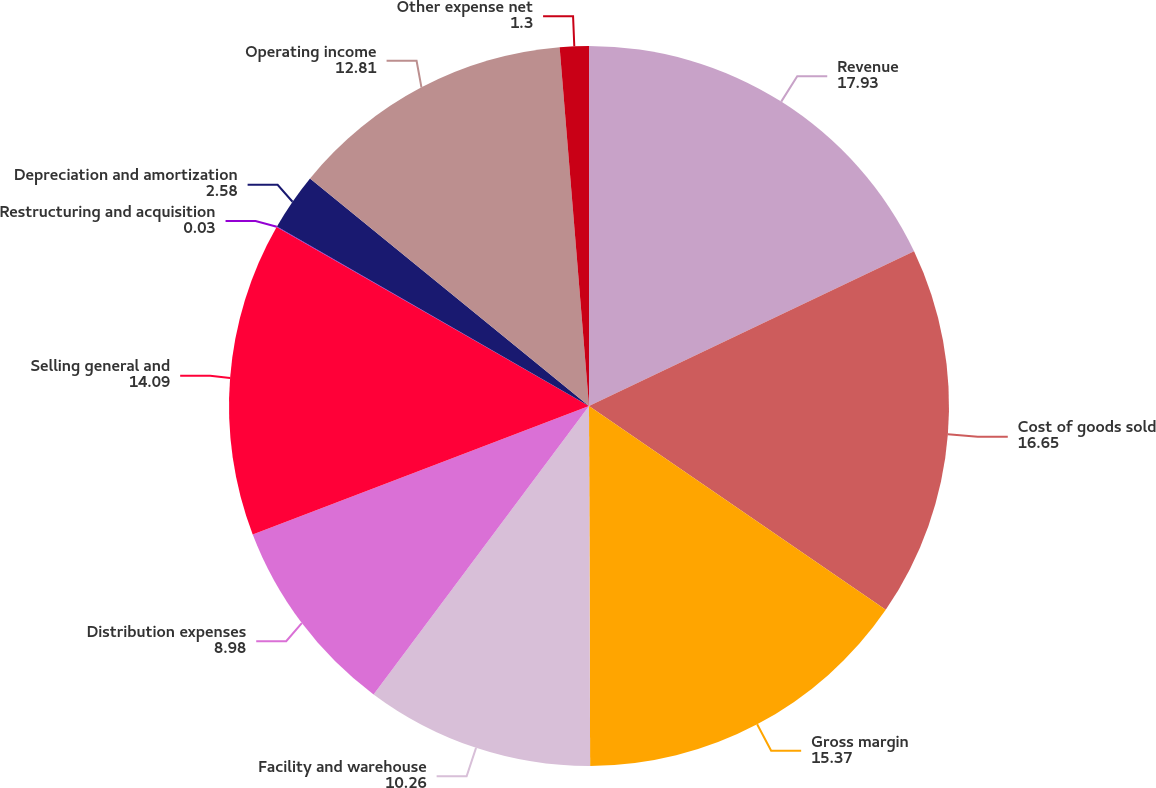Convert chart. <chart><loc_0><loc_0><loc_500><loc_500><pie_chart><fcel>Revenue<fcel>Cost of goods sold<fcel>Gross margin<fcel>Facility and warehouse<fcel>Distribution expenses<fcel>Selling general and<fcel>Restructuring and acquisition<fcel>Depreciation and amortization<fcel>Operating income<fcel>Other expense net<nl><fcel>17.93%<fcel>16.65%<fcel>15.37%<fcel>10.26%<fcel>8.98%<fcel>14.09%<fcel>0.03%<fcel>2.58%<fcel>12.81%<fcel>1.3%<nl></chart> 